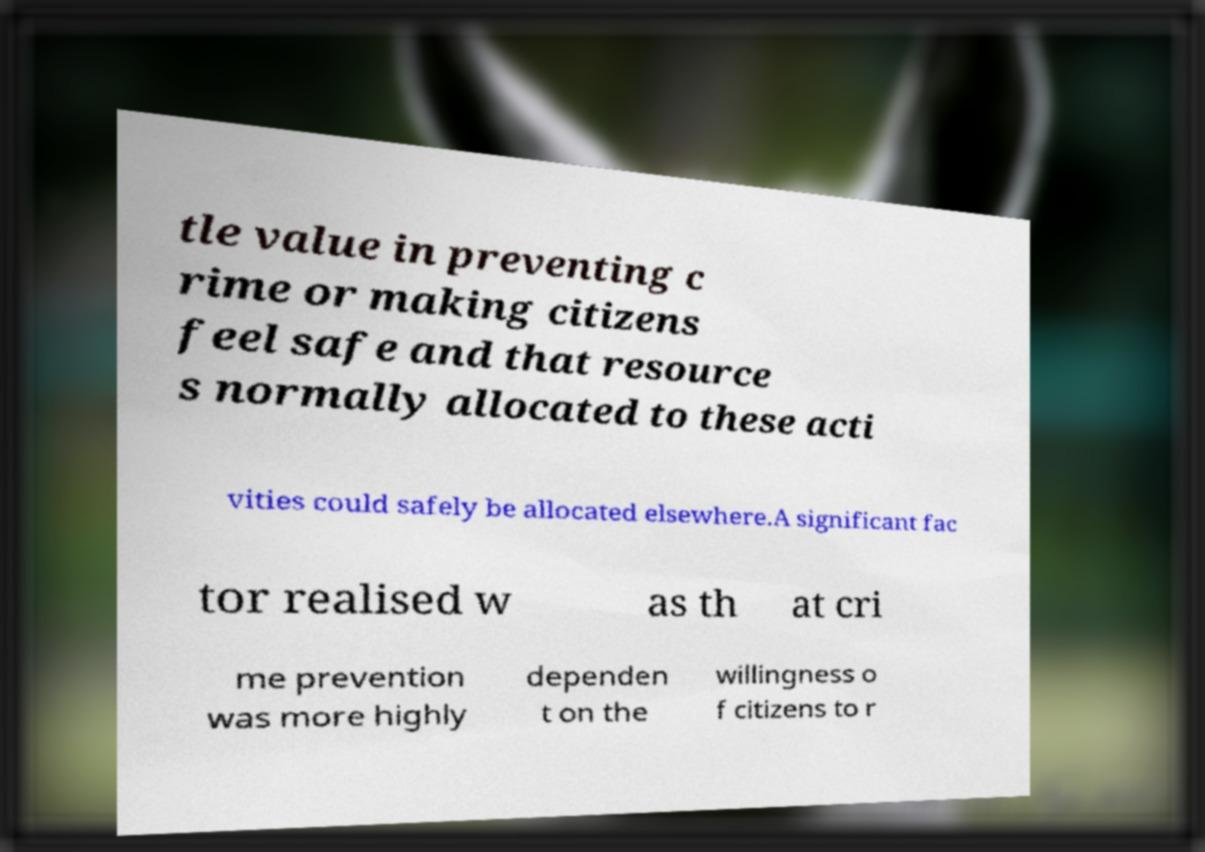Please read and relay the text visible in this image. What does it say? tle value in preventing c rime or making citizens feel safe and that resource s normally allocated to these acti vities could safely be allocated elsewhere.A significant fac tor realised w as th at cri me prevention was more highly dependen t on the willingness o f citizens to r 